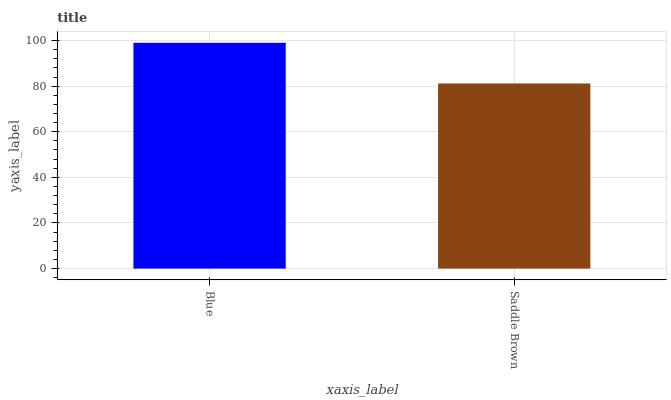Is Saddle Brown the minimum?
Answer yes or no. Yes. Is Blue the maximum?
Answer yes or no. Yes. Is Saddle Brown the maximum?
Answer yes or no. No. Is Blue greater than Saddle Brown?
Answer yes or no. Yes. Is Saddle Brown less than Blue?
Answer yes or no. Yes. Is Saddle Brown greater than Blue?
Answer yes or no. No. Is Blue less than Saddle Brown?
Answer yes or no. No. Is Blue the high median?
Answer yes or no. Yes. Is Saddle Brown the low median?
Answer yes or no. Yes. Is Saddle Brown the high median?
Answer yes or no. No. Is Blue the low median?
Answer yes or no. No. 